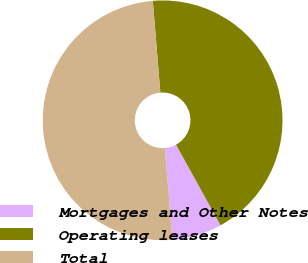Convert chart to OTSL. <chart><loc_0><loc_0><loc_500><loc_500><pie_chart><fcel>Mortgages and Other Notes<fcel>Operating leases<fcel>Total<nl><fcel>6.72%<fcel>43.28%<fcel>50.0%<nl></chart> 